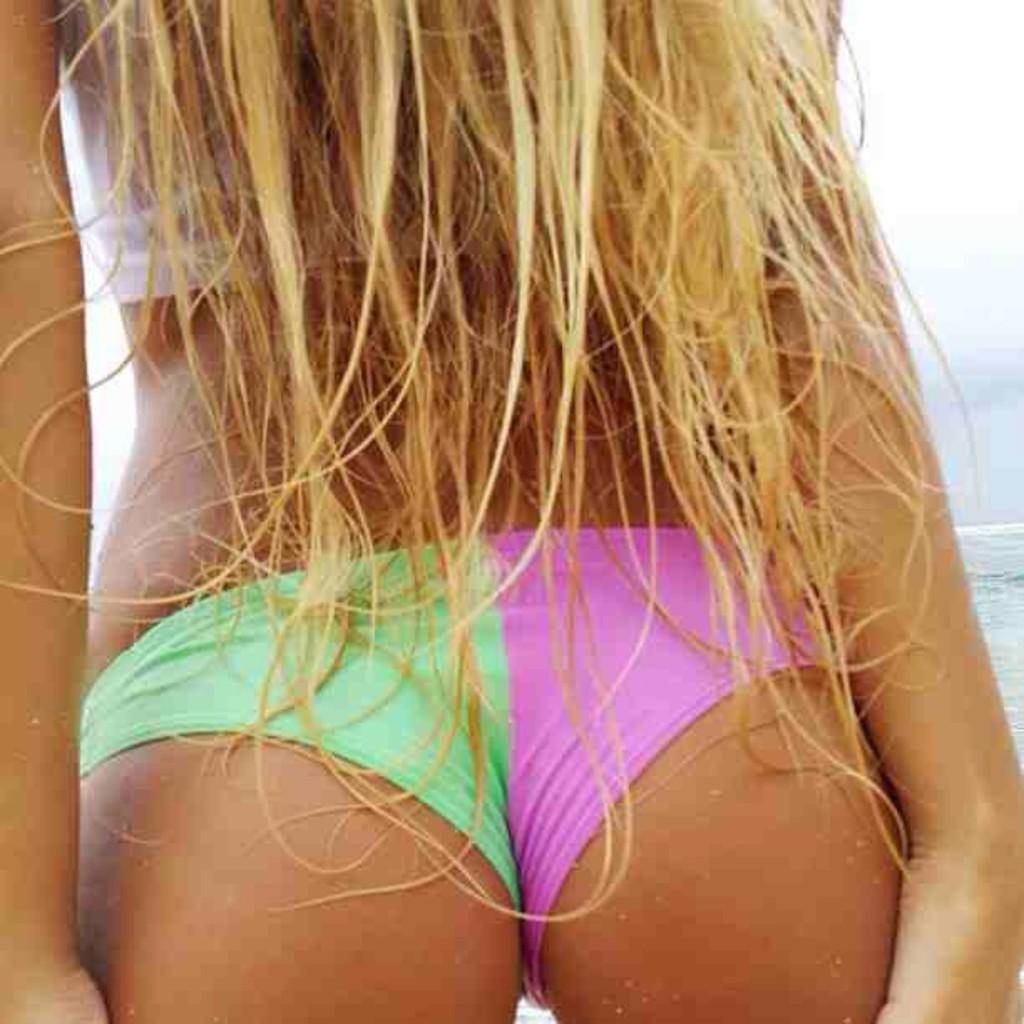Please provide a concise description of this image. In this picture we can see a woman, water and in the background we can see the sky. 